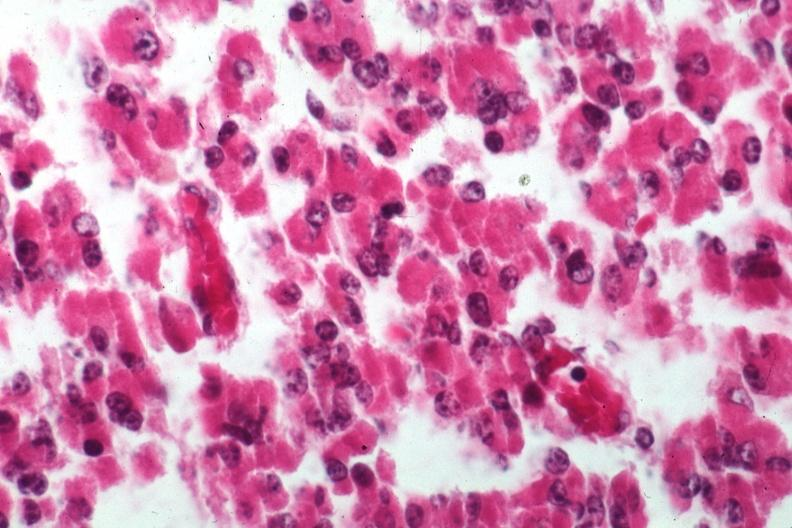s pituitary present?
Answer the question using a single word or phrase. Yes 